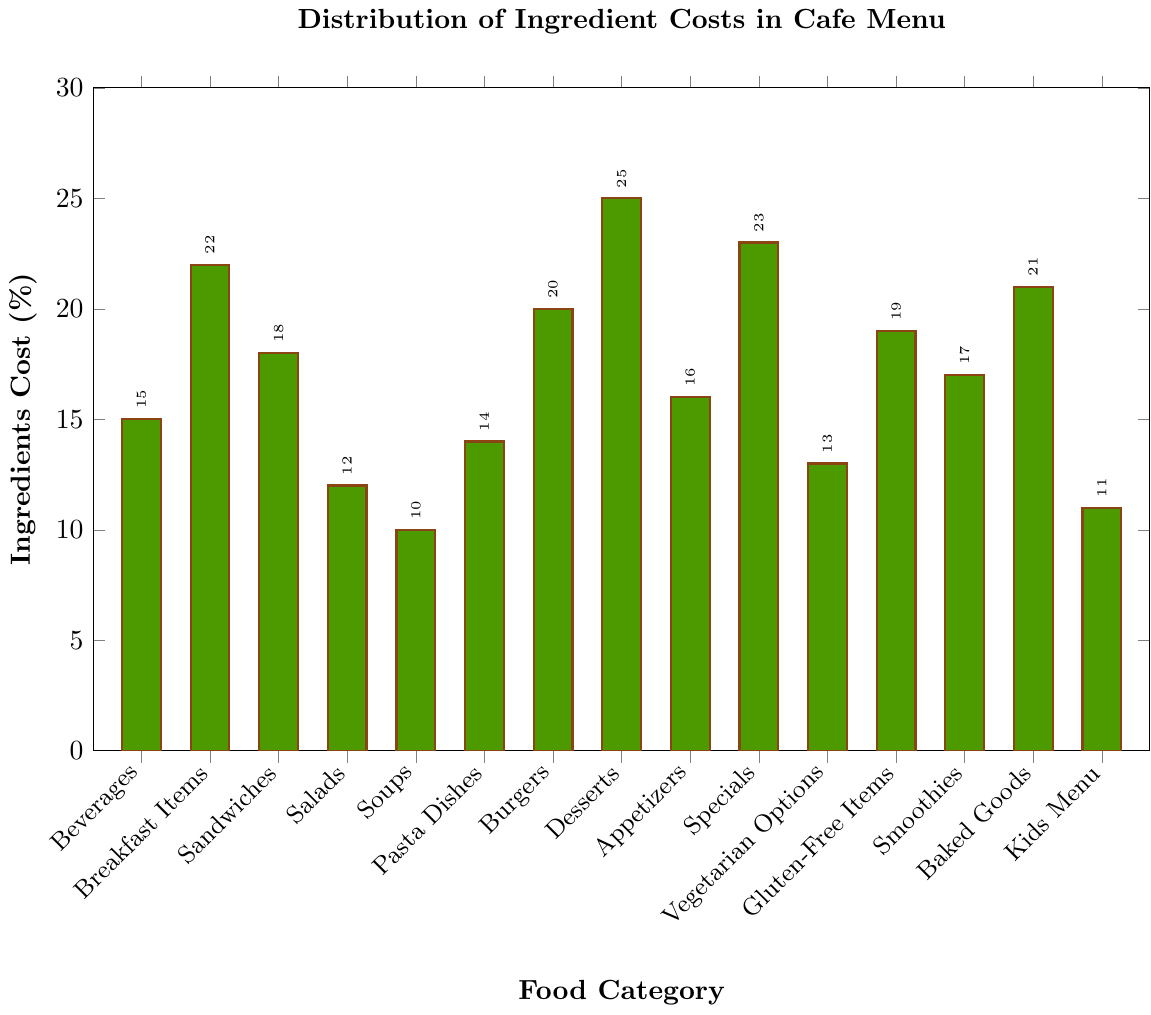what food category has the lowest ingredient cost? From the chart, we see that 'Soups' have the bar with the shortest height, indicating the lowest percentage.
Answer: Soups which food category has the highest ingredient cost? Observing the chart, 'Desserts' has the tallest bar, indicating the highest percentage.
Answer: Desserts how much more is the ingredient cost for 'Breakfast Items' compared to 'Salads'? By looking at the chart, 'Breakfast Items' are at 22% and 'Salads' are at 12%. The difference is 22% - 12% = 10%.
Answer: 10 what is the average ingredient cost across all categories? Adding up all the ingredient costs: 15 + 22 + 18 + 12 + 10 + 14 + 20 + 25 + 16 + 23 + 13 + 19 + 17 + 21 + 11 = 256. There are 15 categories, so the average is 256 / 15 ≈ 17.07%.
Answer: 17.07 which categories have ingredient costs above 20%? By looking closely at the bars, 'Breakfast Items' (22%), 'Desserts' (25%), 'Specials' (23%), and 'Baked Goods' (21%) have costs above 20%.
Answer: Breakfast Items, Desserts, Specials, Baked Goods are 'Appetizers' or 'Smoothies' more costly in terms of ingredients? Observing the bar heights, 'Appetizers' are at 16%, while 'Smoothies' are at 17%, making 'Smoothies' more costly.
Answer: Smoothies what is the difference in ingredient cost between the highest and lowest categories? The highest ingredient cost is 'Desserts' at 25%, and the lowest is 'Soups' at 10%. The difference is 25% - 10% = 15%.
Answer: 15 which category has an ingredient cost equal to the average calculated? Given the average of 17.07%, 'Smoothies' have a cost closest to this average at 17%.
Answer: Smoothies which three categories have the closest ingredient costs? By inspecting the chart, the three categories with closest costs are 'Pasta Dishes' (14%), 'Vegetarian Options' (13%), and 'Salads' (12%) with a minimal difference between them.
Answer: Pasta Dishes, Vegetarian Options, Salads 